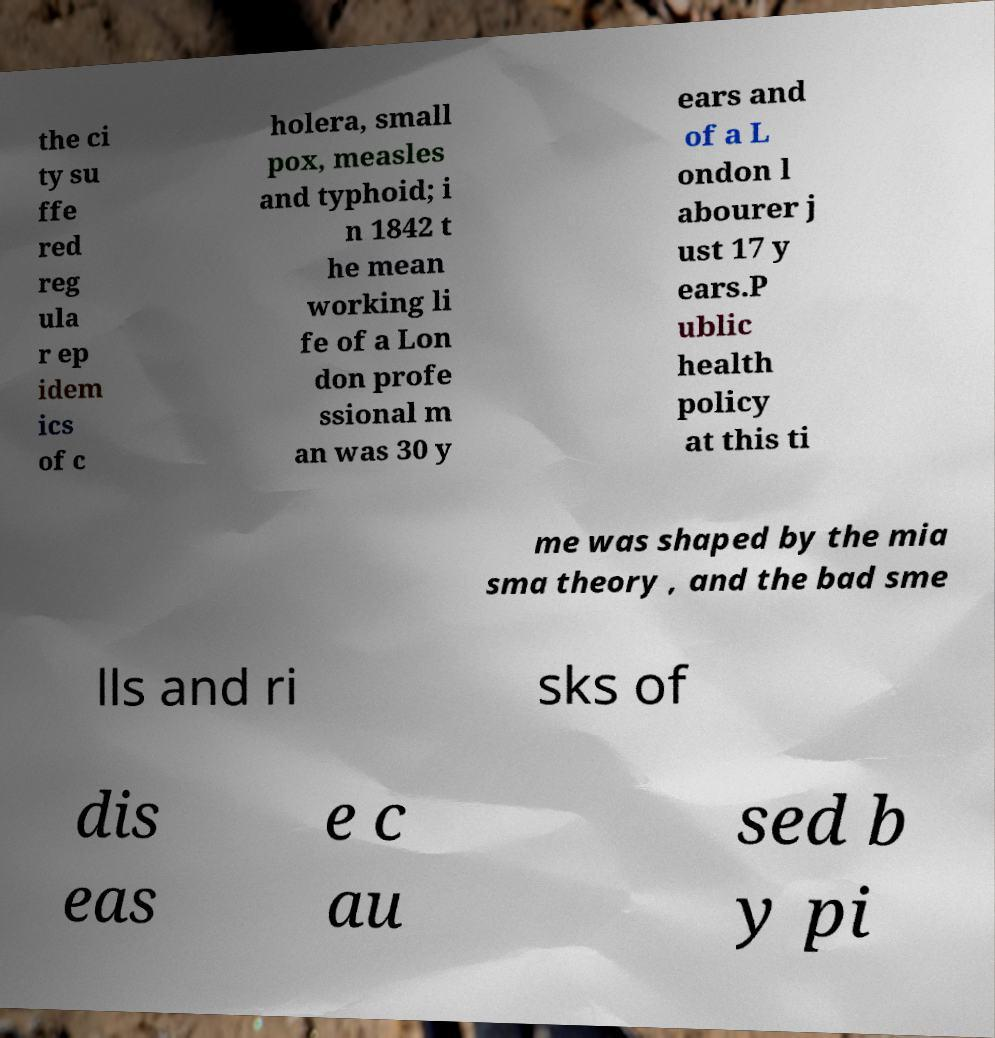Could you assist in decoding the text presented in this image and type it out clearly? the ci ty su ffe red reg ula r ep idem ics of c holera, small pox, measles and typhoid; i n 1842 t he mean working li fe of a Lon don profe ssional m an was 30 y ears and of a L ondon l abourer j ust 17 y ears.P ublic health policy at this ti me was shaped by the mia sma theory , and the bad sme lls and ri sks of dis eas e c au sed b y pi 